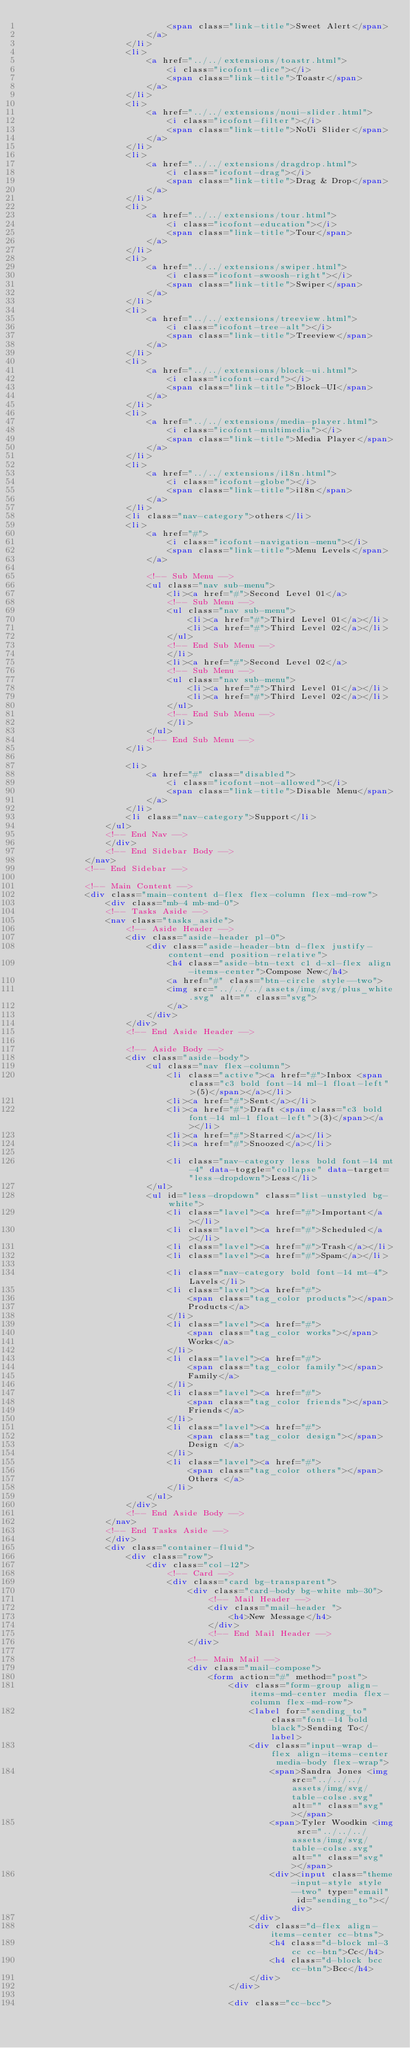Convert code to text. <code><loc_0><loc_0><loc_500><loc_500><_HTML_>                            <span class="link-title">Sweet Alert</span>
                        </a>
                    </li>
                    <li>
                        <a href="../../extensions/toastr.html">
                            <i class="icofont-dice"></i>
                            <span class="link-title">Toastr</span>
                        </a>
                    </li>
                    <li>
                        <a href="../../extensions/noui-slider.html">
                            <i class="icofont-filter"></i>
                            <span class="link-title">NoUi Slider</span>
                        </a>
                    </li>
                    <li>
                        <a href="../../extensions/dragdrop.html">
                            <i class="icofont-drag"></i>
                            <span class="link-title">Drag & Drop</span>
                        </a>
                    </li>
                    <li>
                        <a href="../../extensions/tour.html">
                            <i class="icofont-education"></i>
                            <span class="link-title">Tour</span>
                        </a>
                    </li>
                    <li>
                        <a href="../../extensions/swiper.html">
                            <i class="icofont-swoosh-right"></i>
                            <span class="link-title">Swiper</span>
                        </a>
                    </li>
                    <li>
                        <a href="../../extensions/treeview.html">
                            <i class="icofont-tree-alt"></i>
                            <span class="link-title">Treeview</span>
                        </a>
                    </li>
                    <li>
                        <a href="../../extensions/block-ui.html">
                            <i class="icofont-card"></i>
                            <span class="link-title">Block-UI</span>
                        </a>
                    </li>
                    <li>
                        <a href="../../extensions/media-player.html">
                            <i class="icofont-multimedia"></i>
                            <span class="link-title">Media Player</span>
                        </a>
                    </li>
                    <li>
                        <a href="../../extensions/i18n.html">
                            <i class="icofont-globe"></i>
                            <span class="link-title">i18n</span>
                        </a>
                    </li>
                    <li class="nav-category">others</li>
                    <li>
                        <a href="#">
                            <i class="icofont-navigation-menu"></i>
                            <span class="link-title">Menu Levels</span>
                        </a>

                        <!-- Sub Menu -->
                        <ul class="nav sub-menu">
                            <li><a href="#">Second Level 01</a>
                            <!-- Sub Menu -->
                            <ul class="nav sub-menu">
                                <li><a href="#">Third Level 01</a></li>
                                <li><a href="#">Third Level 02</a></li>
                            </ul>
                            <!-- End Sub Menu -->
                            </li>
                            <li><a href="#">Second Level 02</a>
                            <!-- Sub Menu -->
                            <ul class="nav sub-menu">
                                <li><a href="#">Third Level 01</a></li>
                                <li><a href="#">Third Level 02</a></li>
                            </ul>
                            <!-- End Sub Menu -->
                            </li>
                        </ul>
                        <!-- End Sub Menu -->
                    </li>

                    <li>
                        <a href="#" class="disabled">
                            <i class="icofont-not-allowed"></i>
                            <span class="link-title">Disable Menu</span>
                        </a>
                    </li>
                    <li class="nav-category">Support</li>
                </ul>
                <!-- End Nav -->
                </div>
                <!-- End Sidebar Body -->
            </nav>
            <!-- End Sidebar -->

            <!-- Main Content -->
            <div class="main-content d-flex flex-column flex-md-row">
                <div class="mb-4 mb-md-0">
                <!-- Tasks Aside -->
                <nav class="tasks_aside">
                    <!-- Aside Header -->
                    <div class="aside-header pl-0">
                        <div class="aside-header-btn d-flex justify-content-end position-relative">
                            <h4 class="aside-btn-text c1 d-xl-flex align-items-center">Compose New</h4>
                            <a href="#" class="btn-circle style--two">
                            <img src="../../../assets/img/svg/plus_white.svg" alt="" class="svg">
                            </a>
                        </div>
                    </div>
                    <!-- End Aside Header -->

                    <!-- Aside Body -->
                    <div class="aside-body">
                        <ul class="nav flex-column">
                            <li class="active"><a href="#">Inbox <span class="c3 bold font-14 ml-1 float-left">(5)</span></a></li>
                            <li><a href="#">Sent</a></li>
                            <li><a href="#">Draft <span class="c3 bold font-14 ml-1 float-left">(3)</span></a></li>
                            <li><a href="#">Starred</a></li>
                            <li><a href="#">Snoozed</a></li>

                            <li class="nav-category less bold font-14 mt-4" data-toggle="collapse" data-target="less-dropdown">Less</li>
                        </ul>
                        <ul id="less-dropdown" class="list-unstyled bg-white">
                            <li class="lavel"><a href="#">Important</a></li>
                            <li class="lavel"><a href="#">Scheduled</a></li>
                            <li class="lavel"><a href="#">Trash</a></li>
                            <li class="lavel"><a href="#">Spam</a></li>

                            <li class="nav-category bold font-14 mt-4">Lavels</li>
                            <li class="lavel"><a href="#">
                                <span class="tag_color products"></span>
                                Products</a>
                            </li>
                            <li class="lavel"><a href="#">
                                <span class="tag_color works"></span>
                                Works</a>
                            </li>
                            <li class="lavel"><a href="#">
                                <span class="tag_color family"></span>
                                Family</a>
                            </li>
                            <li class="lavel"><a href="#">
                                <span class="tag_color friends"></span>
                                Friends</a>
                            </li>
                            <li class="lavel"><a href="#">
                                <span class="tag_color design"></span>
                                Design </a>
                            </li>
                            <li class="lavel"><a href="#">
                                <span class="tag_color others"></span>
                                Others </a>
                            </li>
                        </ul>
                    </div>
                    <!-- End Aside Body -->
                </nav>
                <!-- End Tasks Aside -->
                </div>
                <div class="container-fluid">
                    <div class="row">
                        <div class="col-12">
                            <!-- Card -->
                            <div class="card bg-transparent">
                                <div class="card-body bg-white mb-30">
                                    <!-- Mail Header -->
                                    <div class="mail-header ">
                                        <h4>New Message</h4>
                                    </div>
                                    <!-- End Mail Header -->
                                </div>
                                
                                <!-- Main Mail -->
                                <div class="mail-compose">
                                    <form action="#" method="post">
                                        <div class="form-group align-items-md-center media flex-column flex-md-row">
                                            <label for="sending_to" class="font-14 bold black">Sending To</label>
                                            <div class="input-wrap d-flex align-items-center media-body flex-wrap">
                                                <span>Sandra Jones <img src="../../../assets/img/svg/table-colse.svg" alt="" class="svg"></span>
                                                <span>Tyler Woodkin <img src="../../../assets/img/svg/table-colse.svg" alt="" class="svg"></span>
                                                <div><input class="theme-input-style style--two" type="email" id="sending_to"></div>
                                            </div>
                                            <div class="d-flex align-items-center cc-btns">
                                                <h4 class="d-block ml-3 cc cc-btn">Cc</h4>
                                                <h4 class="d-block bcc cc-btn">Bcc</h4>
                                            </div>
                                        </div>

                                        <div class="cc-bcc"></code> 